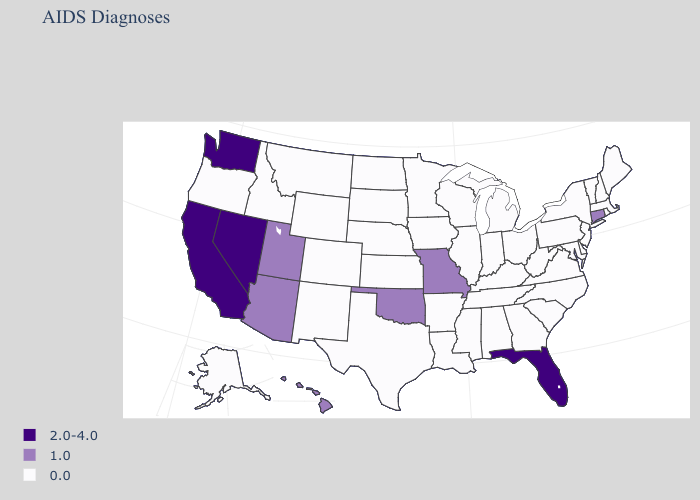What is the value of New Hampshire?
Answer briefly. 0.0. Name the states that have a value in the range 2.0-4.0?
Short answer required. California, Florida, Nevada, Washington. Name the states that have a value in the range 0.0?
Be succinct. Alabama, Alaska, Arkansas, Colorado, Delaware, Georgia, Idaho, Illinois, Indiana, Iowa, Kansas, Kentucky, Louisiana, Maine, Maryland, Massachusetts, Michigan, Minnesota, Mississippi, Montana, Nebraska, New Hampshire, New Jersey, New Mexico, New York, North Carolina, North Dakota, Ohio, Oregon, Pennsylvania, Rhode Island, South Carolina, South Dakota, Tennessee, Texas, Vermont, Virginia, West Virginia, Wisconsin, Wyoming. What is the value of Maine?
Write a very short answer. 0.0. Name the states that have a value in the range 1.0?
Answer briefly. Arizona, Connecticut, Hawaii, Missouri, Oklahoma, Utah. What is the value of Massachusetts?
Concise answer only. 0.0. Name the states that have a value in the range 1.0?
Quick response, please. Arizona, Connecticut, Hawaii, Missouri, Oklahoma, Utah. What is the value of Florida?
Be succinct. 2.0-4.0. What is the value of New Jersey?
Give a very brief answer. 0.0. Which states hav the highest value in the Northeast?
Write a very short answer. Connecticut. What is the value of Massachusetts?
Answer briefly. 0.0. Does Arizona have a lower value than Alabama?
Keep it brief. No. What is the value of Kentucky?
Keep it brief. 0.0. Does New Hampshire have a lower value than Arkansas?
Write a very short answer. No. 